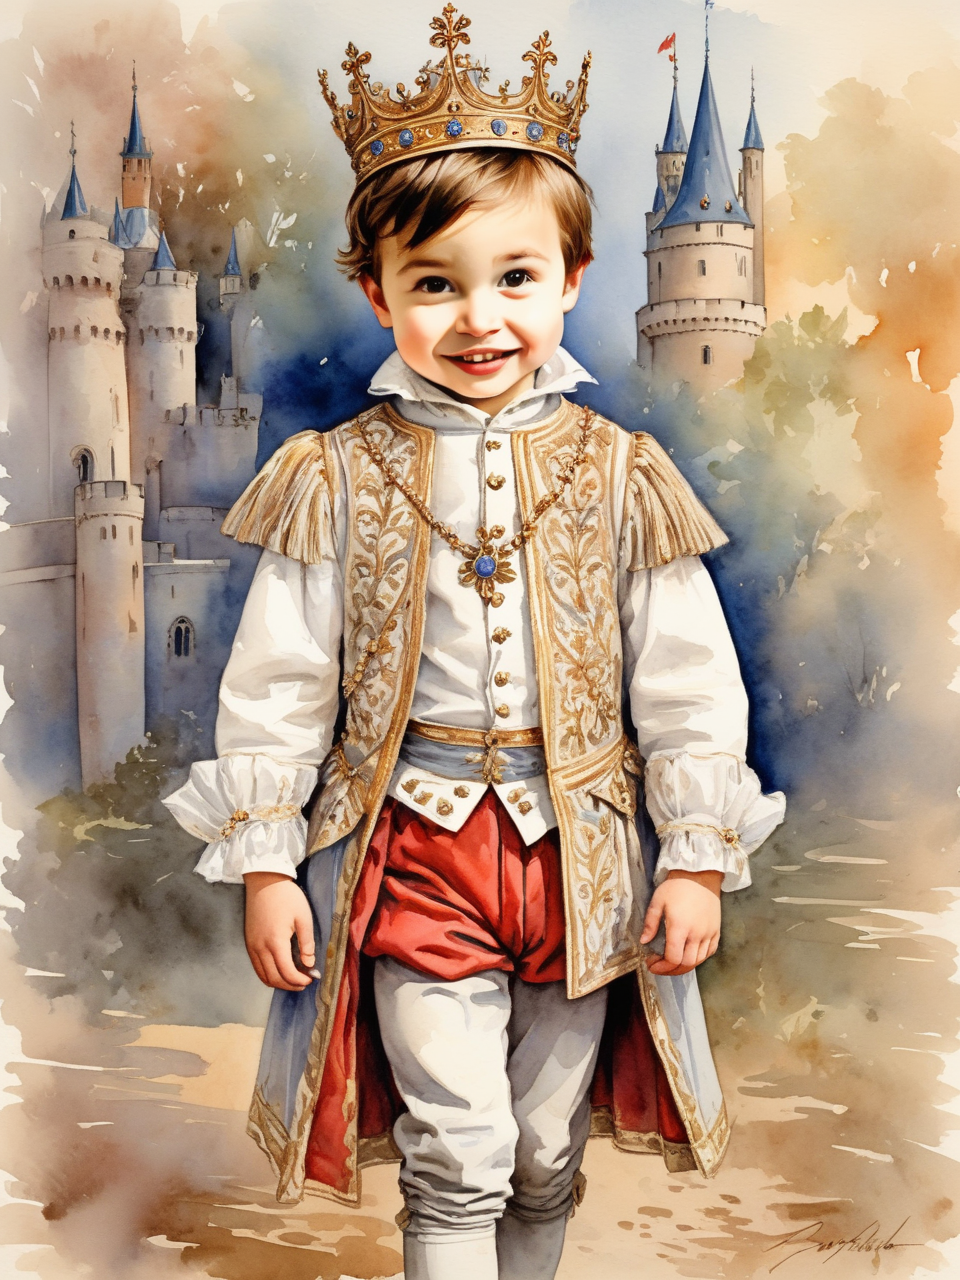From what country is this image inspired? This image is inspired by the country of France. The child is wearing a traditional French outfit, and the background is a French castle. 